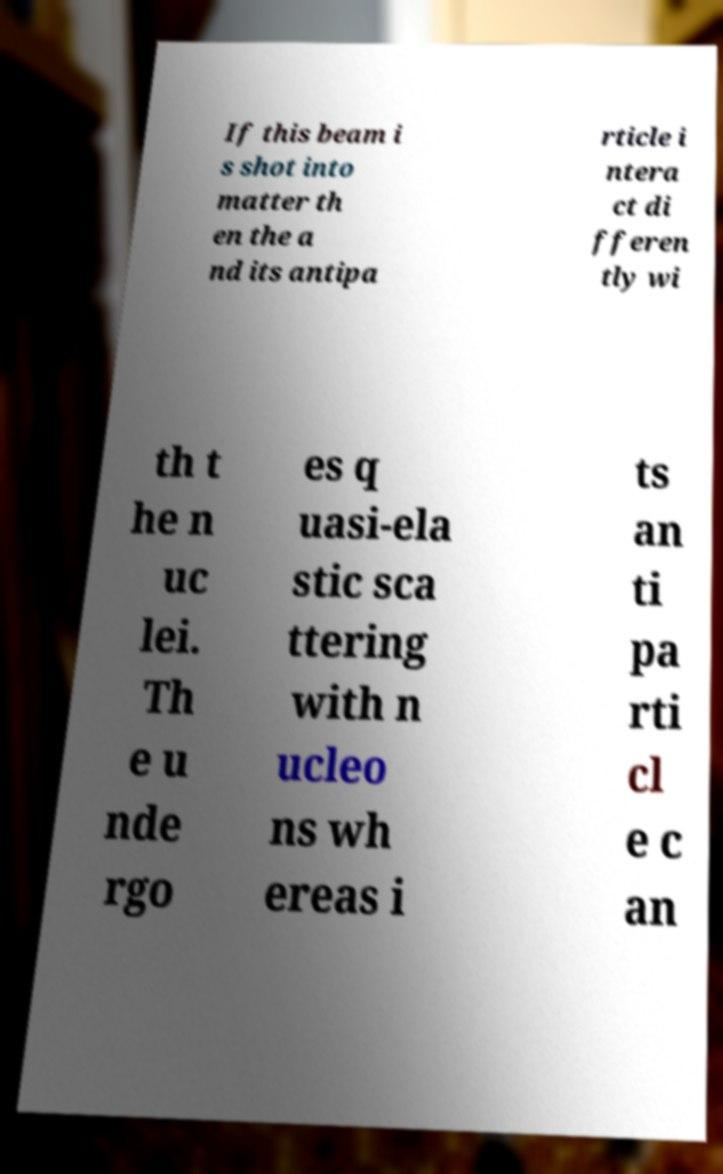Could you assist in decoding the text presented in this image and type it out clearly? If this beam i s shot into matter th en the a nd its antipa rticle i ntera ct di fferen tly wi th t he n uc lei. Th e u nde rgo es q uasi-ela stic sca ttering with n ucleo ns wh ereas i ts an ti pa rti cl e c an 